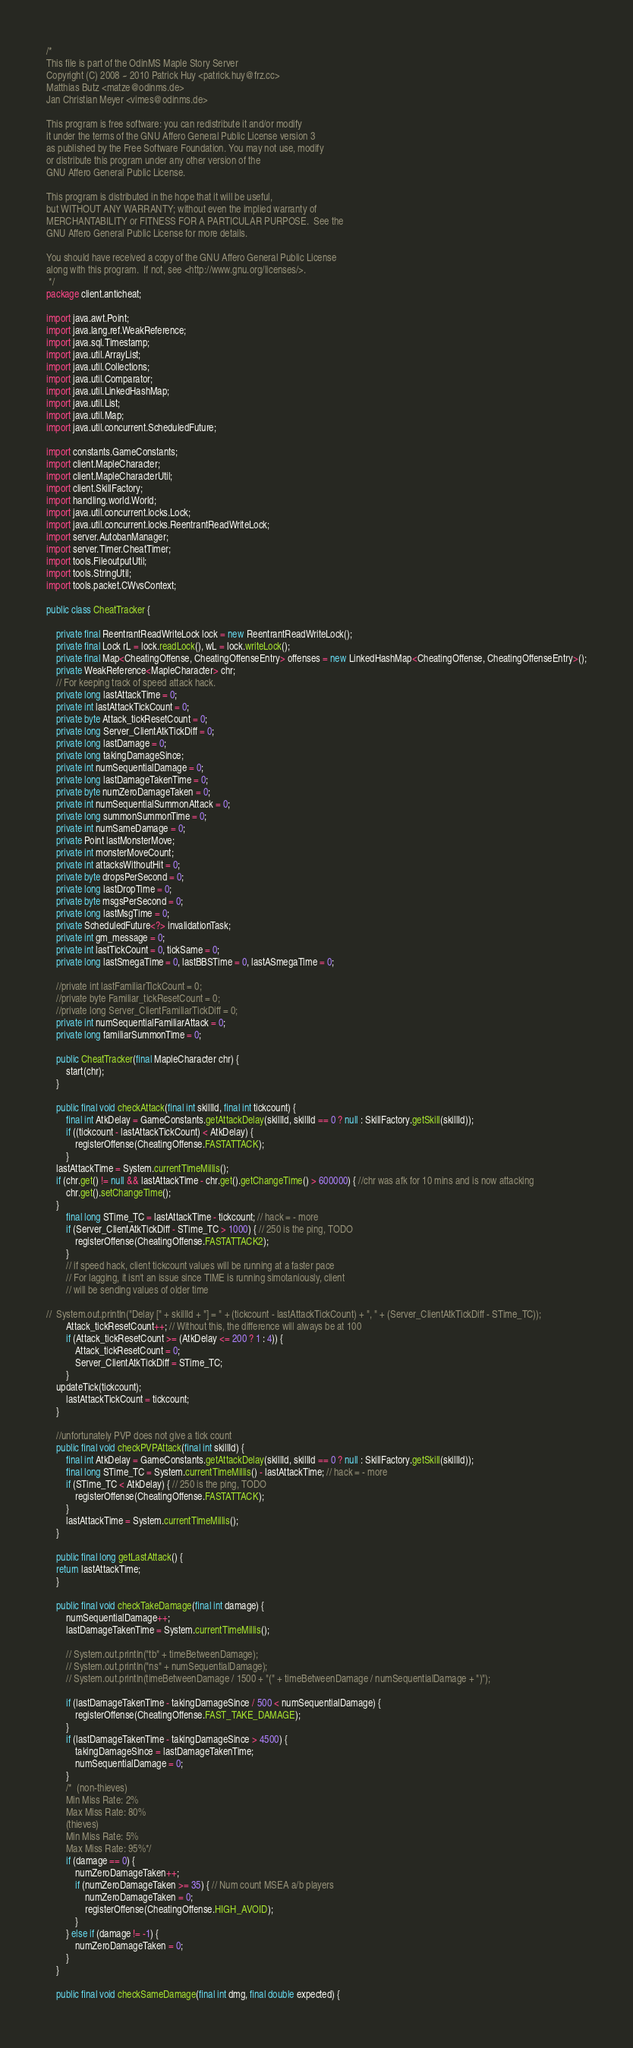<code> <loc_0><loc_0><loc_500><loc_500><_Java_>/*
This file is part of the OdinMS Maple Story Server
Copyright (C) 2008 ~ 2010 Patrick Huy <patrick.huy@frz.cc> 
Matthias Butz <matze@odinms.de>
Jan Christian Meyer <vimes@odinms.de>

This program is free software: you can redistribute it and/or modify
it under the terms of the GNU Affero General Public License version 3
as published by the Free Software Foundation. You may not use, modify
or distribute this program under any other version of the
GNU Affero General Public License.

This program is distributed in the hope that it will be useful,
but WITHOUT ANY WARRANTY; without even the implied warranty of
MERCHANTABILITY or FITNESS FOR A PARTICULAR PURPOSE.  See the
GNU Affero General Public License for more details.

You should have received a copy of the GNU Affero General Public License
along with this program.  If not, see <http://www.gnu.org/licenses/>.
 */
package client.anticheat;

import java.awt.Point;
import java.lang.ref.WeakReference;
import java.sql.Timestamp;
import java.util.ArrayList;
import java.util.Collections;
import java.util.Comparator;
import java.util.LinkedHashMap;
import java.util.List;
import java.util.Map;
import java.util.concurrent.ScheduledFuture;

import constants.GameConstants;
import client.MapleCharacter;
import client.MapleCharacterUtil;
import client.SkillFactory;
import handling.world.World;
import java.util.concurrent.locks.Lock;
import java.util.concurrent.locks.ReentrantReadWriteLock;
import server.AutobanManager;
import server.Timer.CheatTimer;
import tools.FileoutputUtil;
import tools.StringUtil;
import tools.packet.CWvsContext;

public class CheatTracker {

    private final ReentrantReadWriteLock lock = new ReentrantReadWriteLock();
    private final Lock rL = lock.readLock(), wL = lock.writeLock();
    private final Map<CheatingOffense, CheatingOffenseEntry> offenses = new LinkedHashMap<CheatingOffense, CheatingOffenseEntry>();
    private WeakReference<MapleCharacter> chr;
    // For keeping track of speed attack hack.
    private long lastAttackTime = 0;
    private int lastAttackTickCount = 0;
    private byte Attack_tickResetCount = 0;
    private long Server_ClientAtkTickDiff = 0;
    private long lastDamage = 0;
    private long takingDamageSince;
    private int numSequentialDamage = 0;
    private long lastDamageTakenTime = 0;
    private byte numZeroDamageTaken = 0;
    private int numSequentialSummonAttack = 0;
    private long summonSummonTime = 0;
    private int numSameDamage = 0;
    private Point lastMonsterMove;
    private int monsterMoveCount;
    private int attacksWithoutHit = 0;
    private byte dropsPerSecond = 0;
    private long lastDropTime = 0;
    private byte msgsPerSecond = 0;
    private long lastMsgTime = 0;
    private ScheduledFuture<?> invalidationTask;
    private int gm_message = 0;
    private int lastTickCount = 0, tickSame = 0;
    private long lastSmegaTime = 0, lastBBSTime = 0, lastASmegaTime = 0;
	
    //private int lastFamiliarTickCount = 0;
    //private byte Familiar_tickResetCount = 0;
    //private long Server_ClientFamiliarTickDiff = 0;
    private int numSequentialFamiliarAttack = 0;
    private long familiarSummonTime = 0;

    public CheatTracker(final MapleCharacter chr) {
        start(chr);
    }

    public final void checkAttack(final int skillId, final int tickcount) {
        final int AtkDelay = GameConstants.getAttackDelay(skillId, skillId == 0 ? null : SkillFactory.getSkill(skillId));
        if ((tickcount - lastAttackTickCount) < AtkDelay) {
            registerOffense(CheatingOffense.FASTATTACK);
        }
	lastAttackTime = System.currentTimeMillis();
	if (chr.get() != null && lastAttackTime - chr.get().getChangeTime() > 600000) { //chr was afk for 10 mins and is now attacking
	    chr.get().setChangeTime();
	} 
        final long STime_TC = lastAttackTime - tickcount; // hack = - more
        if (Server_ClientAtkTickDiff - STime_TC > 1000) { // 250 is the ping, TODO
            registerOffense(CheatingOffense.FASTATTACK2);
        }
        // if speed hack, client tickcount values will be running at a faster pace
        // For lagging, it isn't an issue since TIME is running simotaniously, client
        // will be sending values of older time

//	System.out.println("Delay [" + skillId + "] = " + (tickcount - lastAttackTickCount) + ", " + (Server_ClientAtkTickDiff - STime_TC));
        Attack_tickResetCount++; // Without this, the difference will always be at 100
        if (Attack_tickResetCount >= (AtkDelay <= 200 ? 1 : 4)) {
            Attack_tickResetCount = 0;
            Server_ClientAtkTickDiff = STime_TC;
        }
	updateTick(tickcount);
        lastAttackTickCount = tickcount;
    }
	
	//unfortunately PVP does not give a tick count
    public final void checkPVPAttack(final int skillId) {
        final int AtkDelay = GameConstants.getAttackDelay(skillId, skillId == 0 ? null : SkillFactory.getSkill(skillId));
        final long STime_TC = System.currentTimeMillis() - lastAttackTime; // hack = - more
        if (STime_TC < AtkDelay) { // 250 is the ping, TODO
            registerOffense(CheatingOffense.FASTATTACK);
        }
		lastAttackTime = System.currentTimeMillis();
    }

    public final long getLastAttack() {
	return lastAttackTime;
    }

    public final void checkTakeDamage(final int damage) {
        numSequentialDamage++;
        lastDamageTakenTime = System.currentTimeMillis();

        // System.out.println("tb" + timeBetweenDamage);
        // System.out.println("ns" + numSequentialDamage);
        // System.out.println(timeBetweenDamage / 1500 + "(" + timeBetweenDamage / numSequentialDamage + ")");

        if (lastDamageTakenTime - takingDamageSince / 500 < numSequentialDamage) {
            registerOffense(CheatingOffense.FAST_TAKE_DAMAGE);
        }
        if (lastDamageTakenTime - takingDamageSince > 4500) {
            takingDamageSince = lastDamageTakenTime;
            numSequentialDamage = 0;
        }
        /*	(non-thieves)
        Min Miss Rate: 2%
        Max Miss Rate: 80%
        (thieves)
        Min Miss Rate: 5%
        Max Miss Rate: 95%*/
        if (damage == 0) {
            numZeroDamageTaken++;
            if (numZeroDamageTaken >= 35) { // Num count MSEA a/b players
                numZeroDamageTaken = 0;
                registerOffense(CheatingOffense.HIGH_AVOID);
            }
        } else if (damage != -1) {
            numZeroDamageTaken = 0;
        }
    }

    public final void checkSameDamage(final int dmg, final double expected) {</code> 